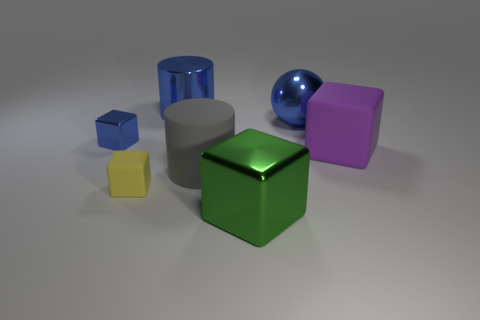The large thing that is the same color as the big shiny sphere is what shape?
Your answer should be compact. Cylinder. Is there any other thing that is the same color as the tiny matte object?
Your answer should be very brief. No. There is a gray rubber cylinder; is it the same size as the purple cube that is in front of the large blue cylinder?
Give a very brief answer. Yes. What number of large things are blue cylinders or blue things?
Give a very brief answer. 2. Is the number of green metal blocks greater than the number of tiny red shiny things?
Ensure brevity in your answer.  Yes. What number of large shiny spheres are to the right of the big metallic thing that is to the left of the large cube that is in front of the purple rubber object?
Keep it short and to the point. 1. What shape is the large green object?
Offer a terse response. Cube. What number of other things are the same material as the large purple block?
Give a very brief answer. 2. Is the gray matte object the same size as the yellow rubber object?
Offer a terse response. No. There is a thing that is behind the ball; what is its shape?
Make the answer very short. Cylinder. 